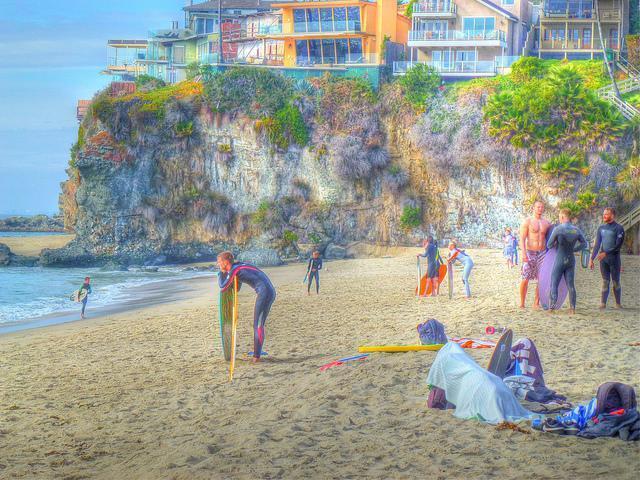How many people can you see?
Give a very brief answer. 2. 